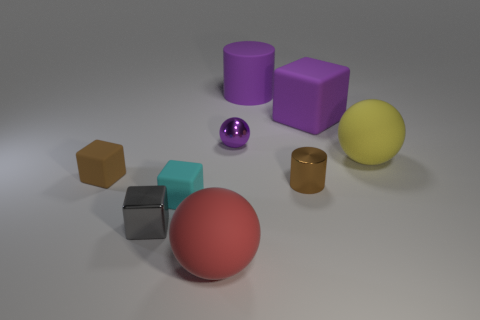Subtract all purple balls. How many balls are left? 2 Subtract all cyan blocks. How many blocks are left? 3 Subtract 2 cubes. How many cubes are left? 2 Subtract all brown balls. Subtract all gray cylinders. How many balls are left? 3 Subtract all cylinders. How many objects are left? 7 Add 1 small green matte cylinders. How many small green matte cylinders exist? 1 Subtract 1 brown cylinders. How many objects are left? 8 Subtract all brown blocks. Subtract all big matte blocks. How many objects are left? 7 Add 5 cyan cubes. How many cyan cubes are left? 6 